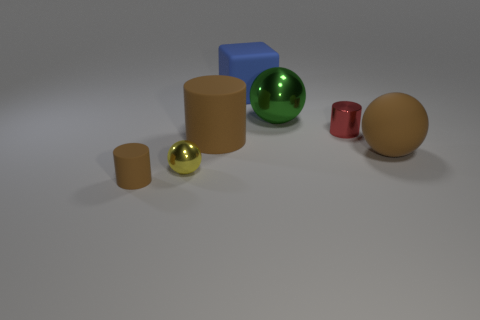Add 1 large brown rubber balls. How many objects exist? 8 Subtract all brown cylinders. How many cylinders are left? 1 Subtract all cyan spheres. How many red cylinders are left? 1 Subtract all yellow spheres. How many spheres are left? 2 Add 4 cylinders. How many cylinders exist? 7 Subtract 0 yellow cubes. How many objects are left? 7 Subtract all cubes. How many objects are left? 6 Subtract all gray balls. Subtract all purple blocks. How many balls are left? 3 Subtract all green metallic things. Subtract all small yellow shiny balls. How many objects are left? 5 Add 2 big cylinders. How many big cylinders are left? 3 